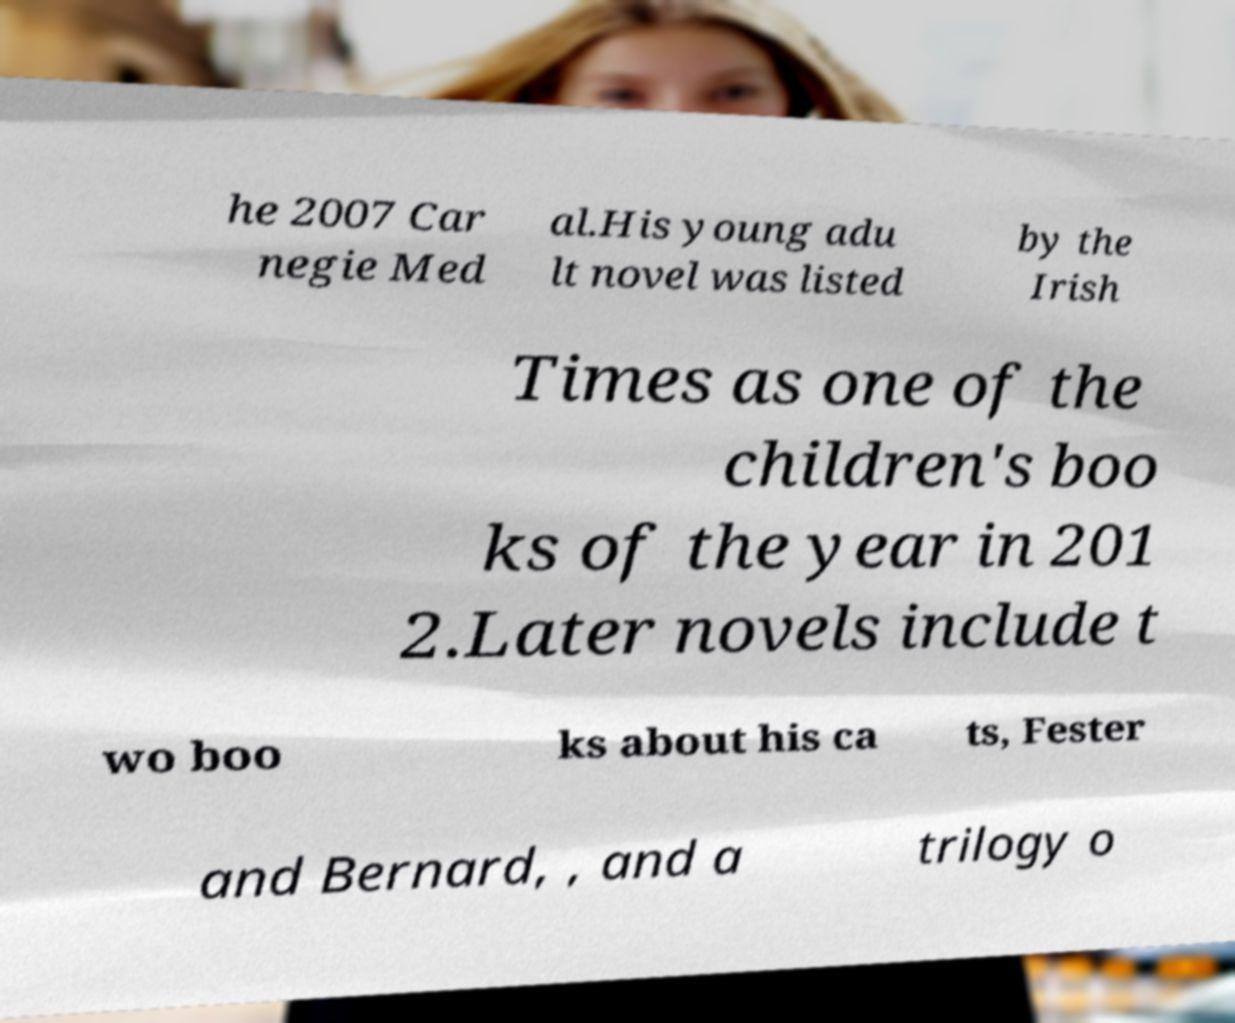For documentation purposes, I need the text within this image transcribed. Could you provide that? he 2007 Car negie Med al.His young adu lt novel was listed by the Irish Times as one of the children's boo ks of the year in 201 2.Later novels include t wo boo ks about his ca ts, Fester and Bernard, , and a trilogy o 